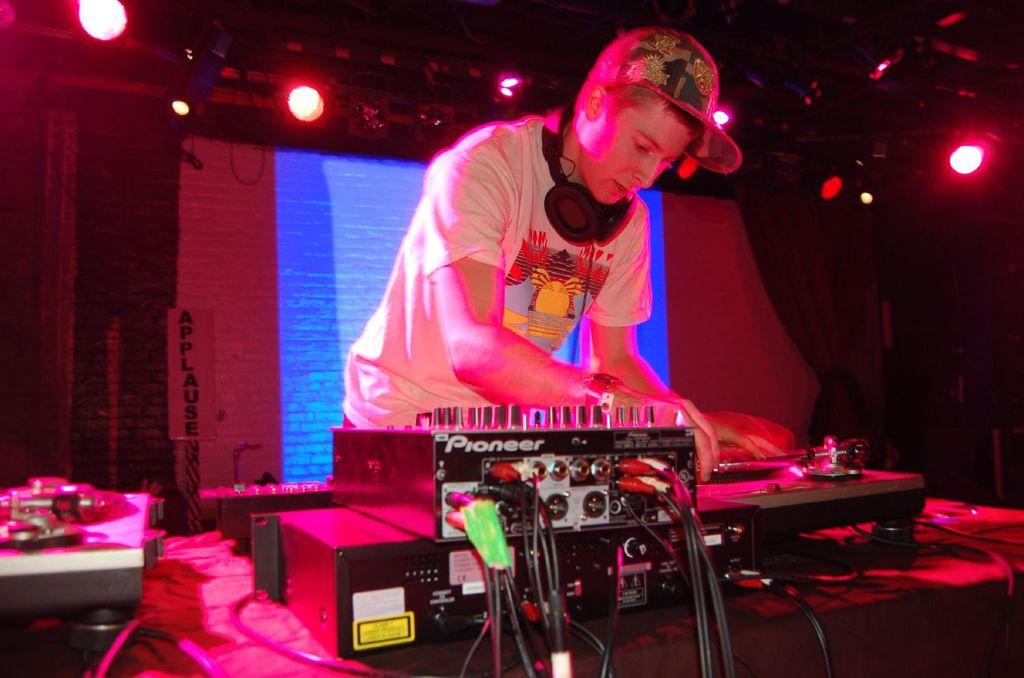What is the main subject of the image? There is a man in the image. What is the man wearing on his head? The man is wearing a cap. What is the man's posture in the image? The man is standing. What type of audio equipment is present in the image? There is a headset in the image. What electronic devices can be seen in the image? There are devices in the image. What type of lighting is present in the image? There are lights in the image. What type of window treatment is present in the image? There are curtains in the image. What type of display is present in the image? There is a screen in the image. How would you describe the overall lighting in the image? The background of the image is dark. What type of zinc is present in the image? There is no zinc present in the image. What type of train can be seen in the image? There is no train present in the image. 